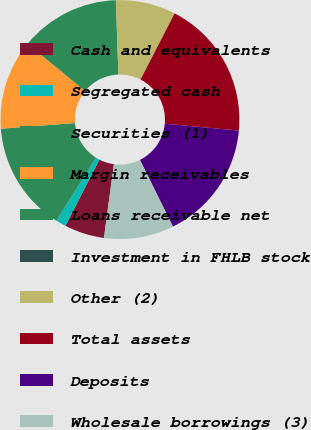<chart> <loc_0><loc_0><loc_500><loc_500><pie_chart><fcel>Cash and equivalents<fcel>Segregated cash<fcel>Securities (1)<fcel>Margin receivables<fcel>Loans receivable net<fcel>Investment in FHLB stock<fcel>Other (2)<fcel>Total assets<fcel>Deposits<fcel>Wholesale borrowings (3)<nl><fcel>5.41%<fcel>1.37%<fcel>14.86%<fcel>12.16%<fcel>13.51%<fcel>0.02%<fcel>8.11%<fcel>18.9%<fcel>16.21%<fcel>9.46%<nl></chart> 